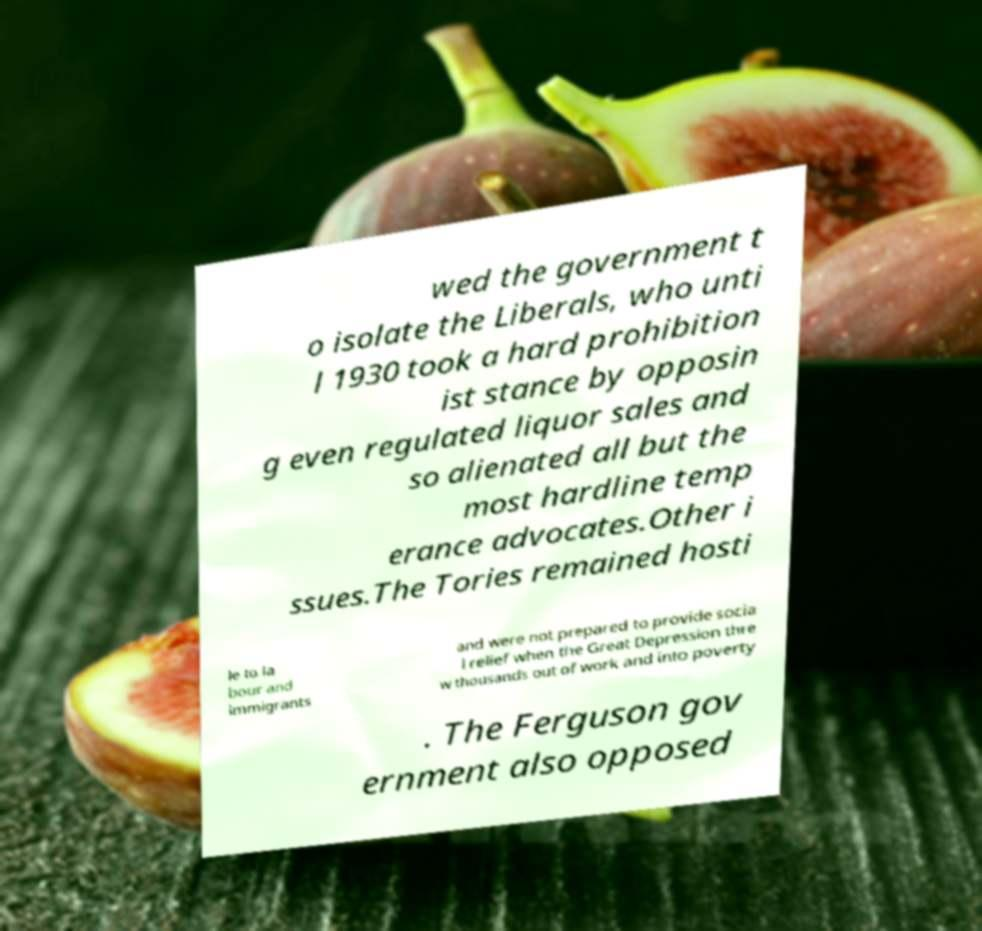Please read and relay the text visible in this image. What does it say? wed the government t o isolate the Liberals, who unti l 1930 took a hard prohibition ist stance by opposin g even regulated liquor sales and so alienated all but the most hardline temp erance advocates.Other i ssues.The Tories remained hosti le to la bour and immigrants and were not prepared to provide socia l relief when the Great Depression thre w thousands out of work and into poverty . The Ferguson gov ernment also opposed 